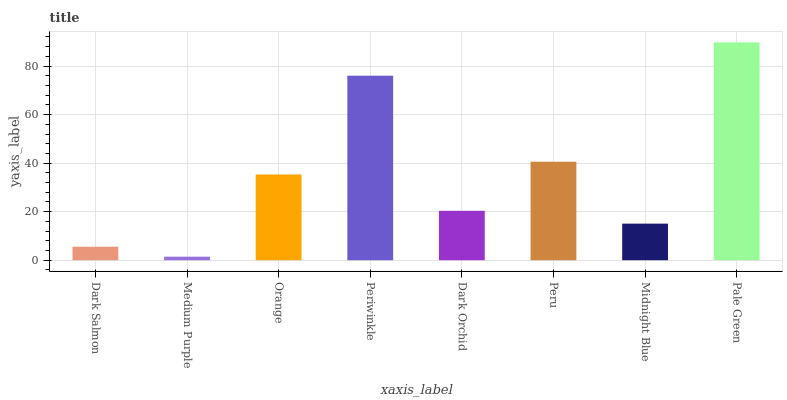Is Medium Purple the minimum?
Answer yes or no. Yes. Is Pale Green the maximum?
Answer yes or no. Yes. Is Orange the minimum?
Answer yes or no. No. Is Orange the maximum?
Answer yes or no. No. Is Orange greater than Medium Purple?
Answer yes or no. Yes. Is Medium Purple less than Orange?
Answer yes or no. Yes. Is Medium Purple greater than Orange?
Answer yes or no. No. Is Orange less than Medium Purple?
Answer yes or no. No. Is Orange the high median?
Answer yes or no. Yes. Is Dark Orchid the low median?
Answer yes or no. Yes. Is Medium Purple the high median?
Answer yes or no. No. Is Periwinkle the low median?
Answer yes or no. No. 